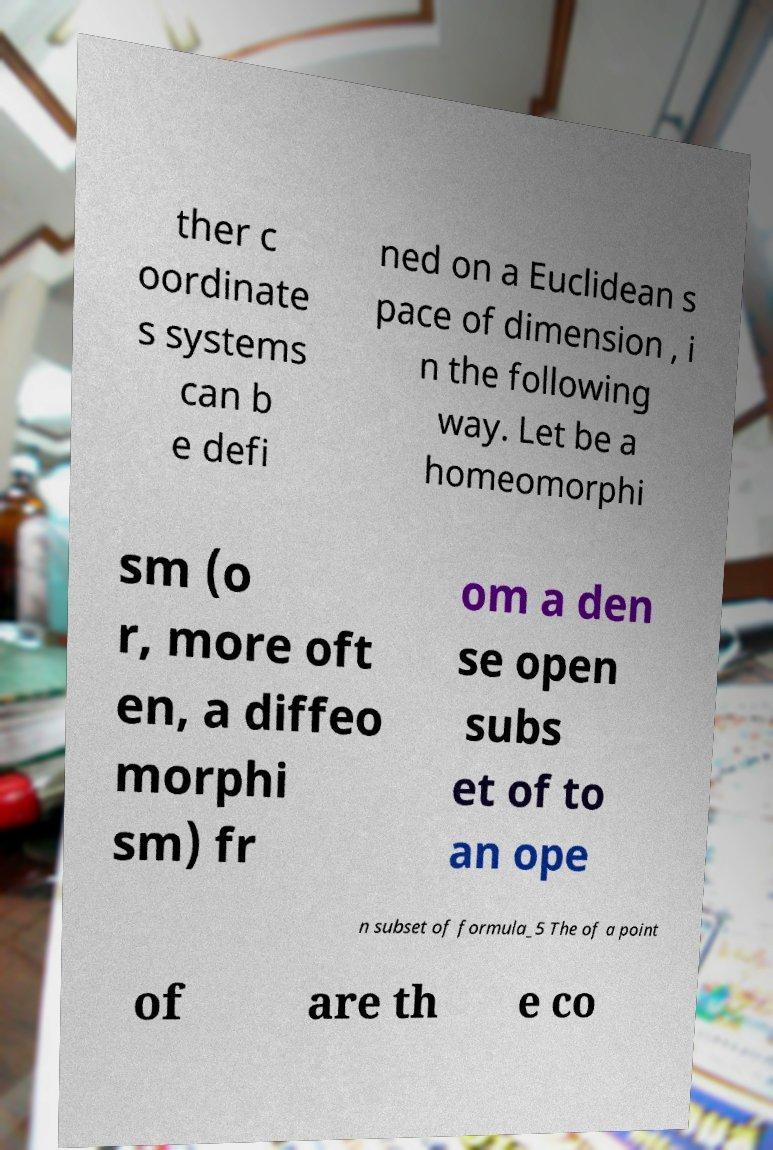I need the written content from this picture converted into text. Can you do that? ther c oordinate s systems can b e defi ned on a Euclidean s pace of dimension , i n the following way. Let be a homeomorphi sm (o r, more oft en, a diffeo morphi sm) fr om a den se open subs et of to an ope n subset of formula_5 The of a point of are th e co 